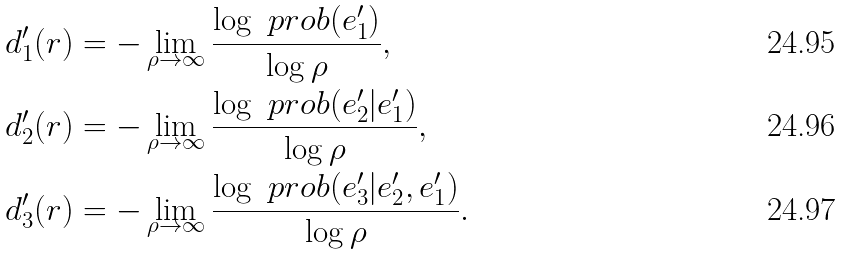<formula> <loc_0><loc_0><loc_500><loc_500>d ^ { \prime } _ { 1 } ( r ) & = - \lim _ { \rho \rightarrow \infty } \frac { \log \ p r o b ( e _ { 1 } ^ { \prime } ) } { \log \rho } , \\ d ^ { \prime } _ { 2 } ( r ) & = - \lim _ { \rho \rightarrow \infty } \frac { \log \ p r o b ( e _ { 2 } ^ { \prime } | e _ { 1 } ^ { \prime } ) } { \log \rho } , \\ d ^ { \prime } _ { 3 } ( r ) & = - \lim _ { \rho \rightarrow \infty } \frac { \log \ p r o b ( e _ { 3 } ^ { \prime } | e _ { 2 } ^ { \prime } , e _ { 1 } ^ { \prime } ) } { \log \rho } .</formula> 